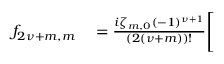Convert formula to latex. <formula><loc_0><loc_0><loc_500><loc_500>\begin{array} { r l } { f _ { 2 { \nu } + m , m } } & = \frac { i \zeta _ { m , 0 } ( - 1 ) ^ { { \nu } + 1 } } { ( 2 ( { \nu } + m ) ) ! } \Big [ } \end{array}</formula> 